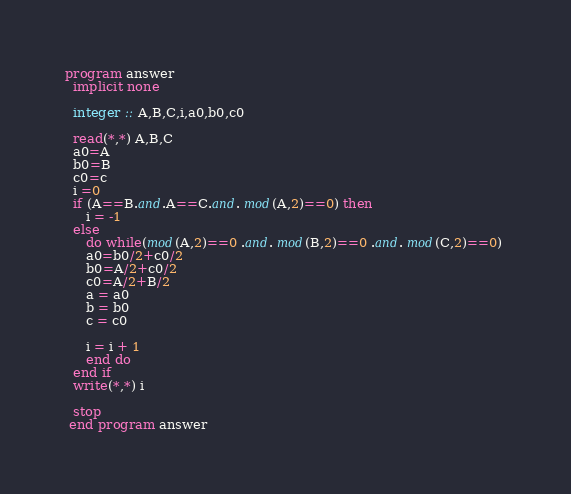Convert code to text. <code><loc_0><loc_0><loc_500><loc_500><_FORTRAN_>program answer
  implicit none

  integer :: A,B,C,i,a0,b0,c0

  read(*,*) A,B,C
  a0=A
  b0=B
  c0=c
  i =0
  if (A==B.and.A==C.and. mod(A,2)==0) then
     i = -1
  else
     do while(mod(A,2)==0 .and. mod(B,2)==0 .and. mod(C,2)==0) 
     a0=b0/2+c0/2
     b0=A/2+c0/2
     c0=A/2+B/2
     a = a0
     b = b0
     c = c0
     
     i = i + 1
     end do
  end if
  write(*,*) i

  stop
 end program answer
</code> 